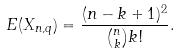<formula> <loc_0><loc_0><loc_500><loc_500>E ( X _ { n , q } ) = \frac { ( n - k + 1 ) ^ { 2 } } { { n \choose k } k ! } .</formula> 